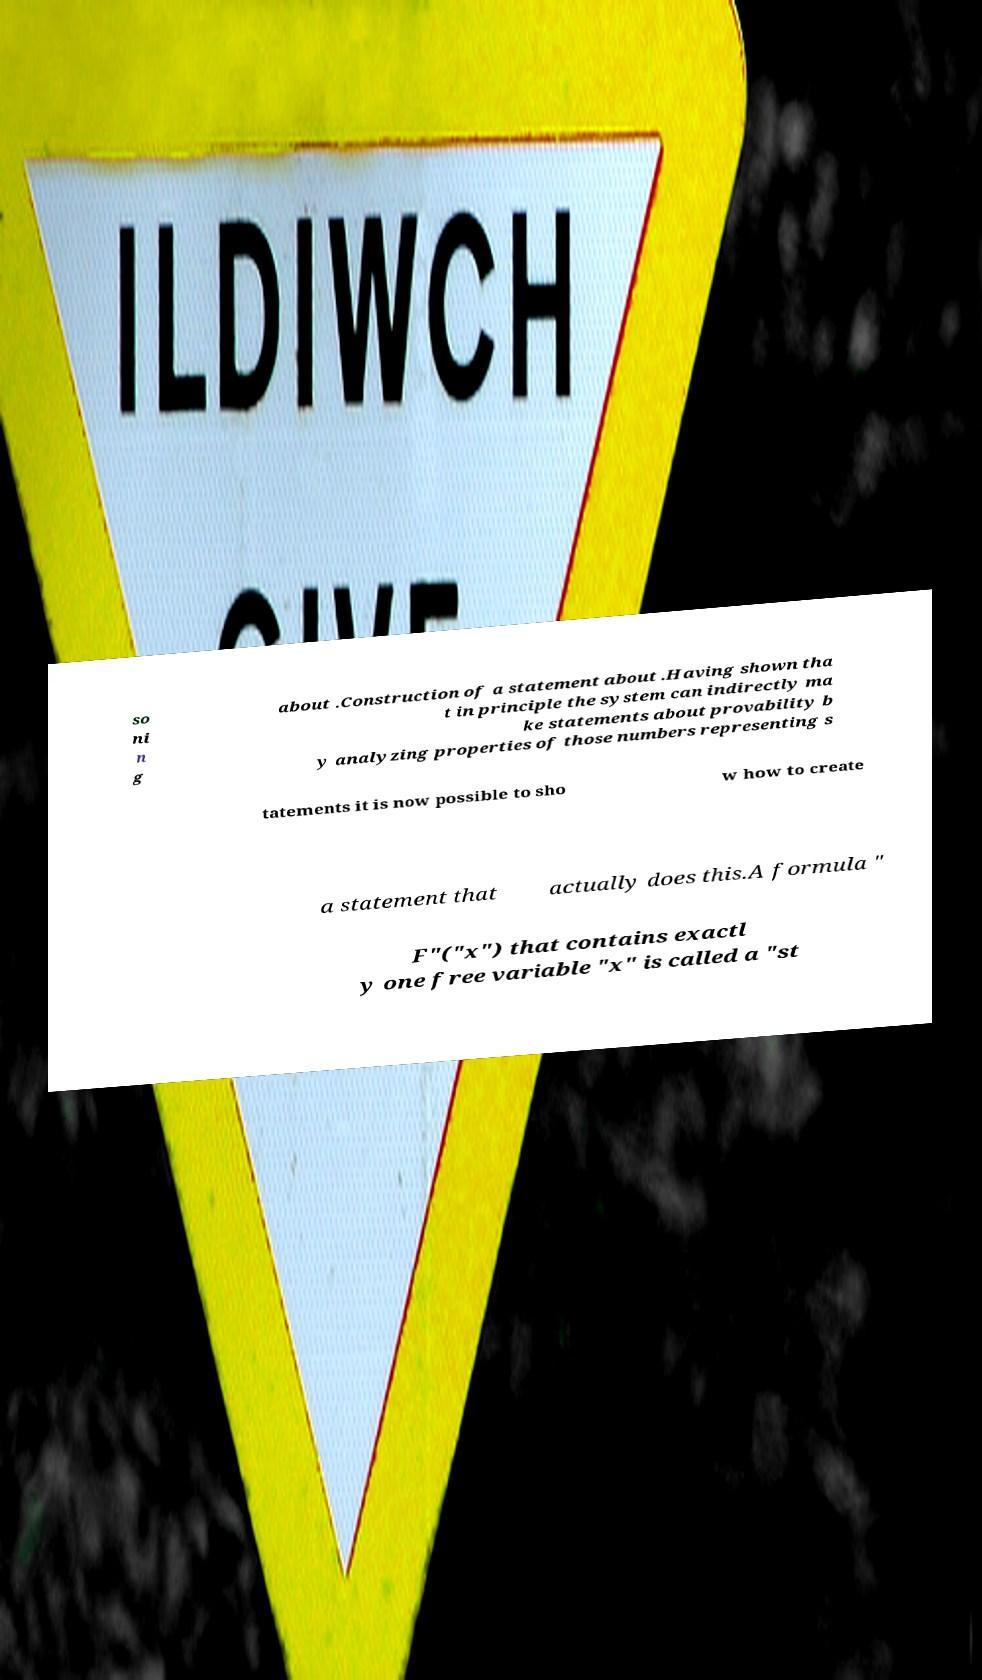What messages or text are displayed in this image? I need them in a readable, typed format. so ni n g about .Construction of a statement about .Having shown tha t in principle the system can indirectly ma ke statements about provability b y analyzing properties of those numbers representing s tatements it is now possible to sho w how to create a statement that actually does this.A formula " F"("x") that contains exactl y one free variable "x" is called a "st 